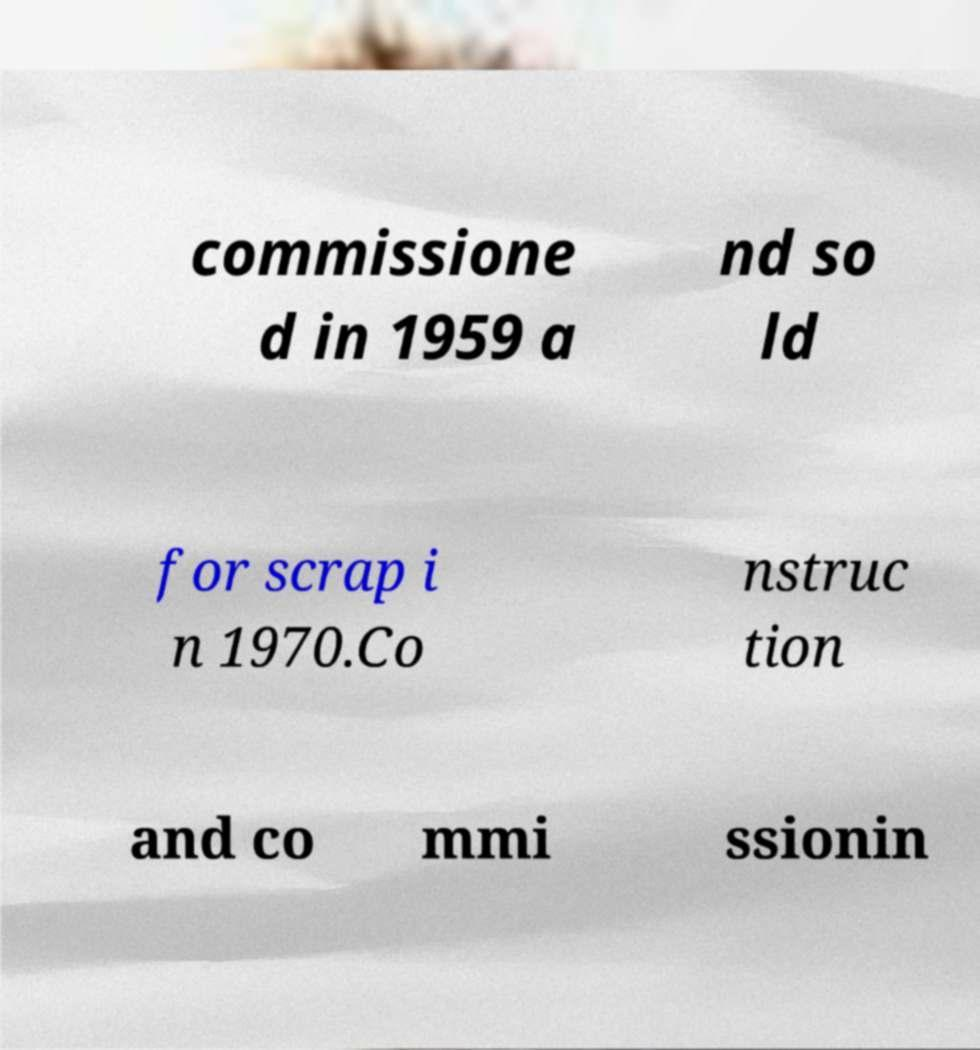For documentation purposes, I need the text within this image transcribed. Could you provide that? commissione d in 1959 a nd so ld for scrap i n 1970.Co nstruc tion and co mmi ssionin 